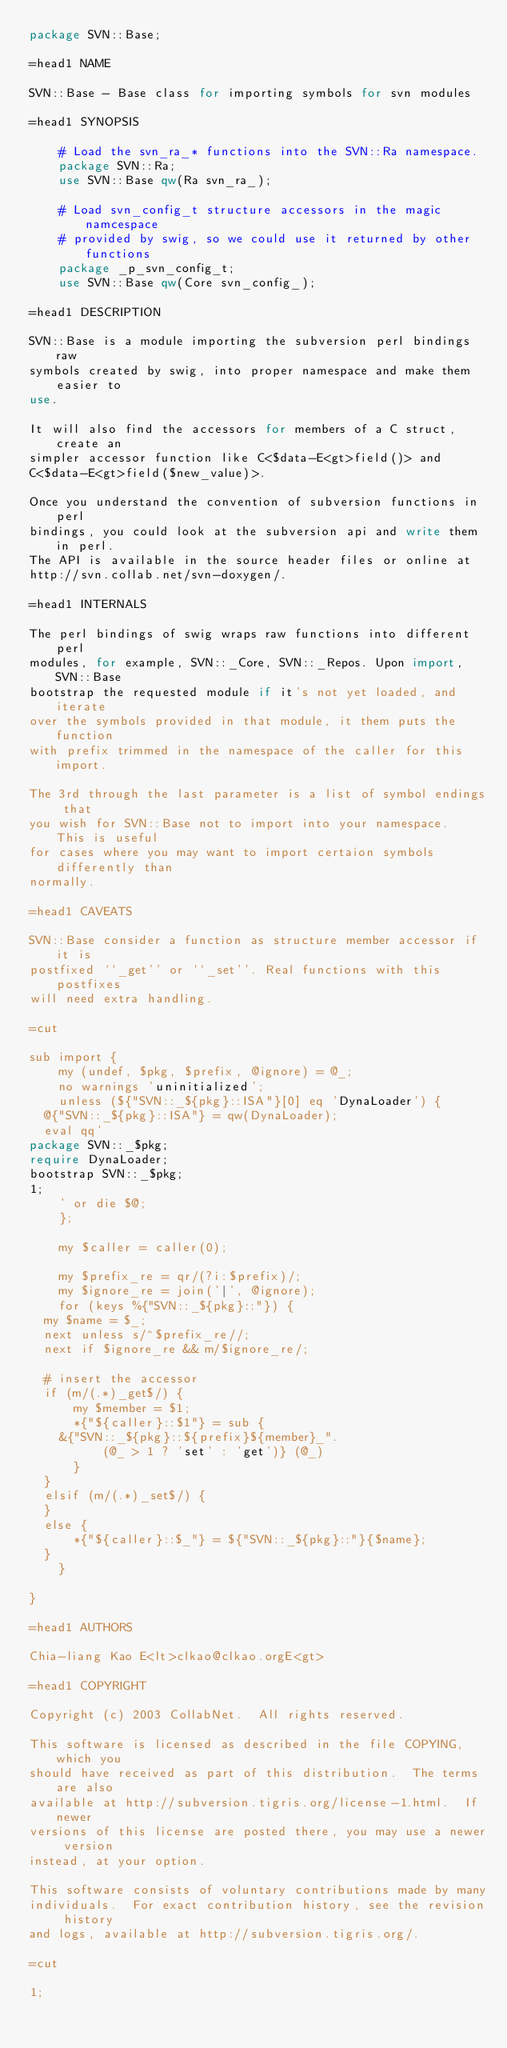<code> <loc_0><loc_0><loc_500><loc_500><_Perl_>package SVN::Base;

=head1 NAME

SVN::Base - Base class for importing symbols for svn modules

=head1 SYNOPSIS

    # Load the svn_ra_* functions into the SVN::Ra namespace.
    package SVN::Ra;
    use SVN::Base qw(Ra svn_ra_);

    # Load svn_config_t structure accessors in the magic namcespace
    # provided by swig, so we could use it returned by other functions
    package _p_svn_config_t;
    use SVN::Base qw(Core svn_config_);

=head1 DESCRIPTION

SVN::Base is a module importing the subversion perl bindings raw
symbols created by swig, into proper namespace and make them easier to
use.

It will also find the accessors for members of a C struct, create an
simpler accessor function like C<$data-E<gt>field()> and
C<$data-E<gt>field($new_value)>.

Once you understand the convention of subversion functions in perl
bindings, you could look at the subversion api and write them in perl.
The API is available in the source header files or online at
http://svn.collab.net/svn-doxygen/.

=head1 INTERNALS

The perl bindings of swig wraps raw functions into different perl
modules, for example, SVN::_Core, SVN::_Repos. Upon import, SVN::Base
bootstrap the requested module if it's not yet loaded, and iterate
over the symbols provided in that module, it them puts the function
with prefix trimmed in the namespace of the caller for this import.

The 3rd through the last parameter is a list of symbol endings that
you wish for SVN::Base not to import into your namespace.  This is useful
for cases where you may want to import certaion symbols differently than
normally.

=head1 CAVEATS

SVN::Base consider a function as structure member accessor if it is
postfixed ``_get'' or ``_set''. Real functions with this postfixes
will need extra handling.

=cut

sub import {
    my (undef, $pkg, $prefix, @ignore) = @_;
    no warnings 'uninitialized';
    unless (${"SVN::_${pkg}::ISA"}[0] eq 'DynaLoader') {
	@{"SVN::_${pkg}::ISA"} = qw(DynaLoader);
	eval qq'
package SVN::_$pkg;
require DynaLoader;
bootstrap SVN::_$pkg;
1;
    ' or die $@;
    };

    my $caller = caller(0);

    my $prefix_re = qr/(?i:$prefix)/;
    my $ignore_re = join('|', @ignore);
    for (keys %{"SVN::_${pkg}::"}) {
	my $name = $_;
	next unless s/^$prefix_re//;
	next if $ignore_re && m/$ignore_re/;

	# insert the accessor
	if (m/(.*)_get$/) {
	    my $member = $1;
	    *{"${caller}::$1"} = sub {
		&{"SVN::_${pkg}::${prefix}${member}_".
		      (@_ > 1 ? 'set' : 'get')} (@_)
		  }
	}
	elsif (m/(.*)_set$/) {
	}
	else {
	    *{"${caller}::$_"} = ${"SVN::_${pkg}::"}{$name};
	}
    }

}

=head1 AUTHORS

Chia-liang Kao E<lt>clkao@clkao.orgE<gt>

=head1 COPYRIGHT

Copyright (c) 2003 CollabNet.  All rights reserved.

This software is licensed as described in the file COPYING, which you
should have received as part of this distribution.  The terms are also
available at http://subversion.tigris.org/license-1.html.  If newer
versions of this license are posted there, you may use a newer version
instead, at your option.

This software consists of voluntary contributions made by many
individuals.  For exact contribution history, see the revision history
and logs, available at http://subversion.tigris.org/.

=cut

1;
</code> 